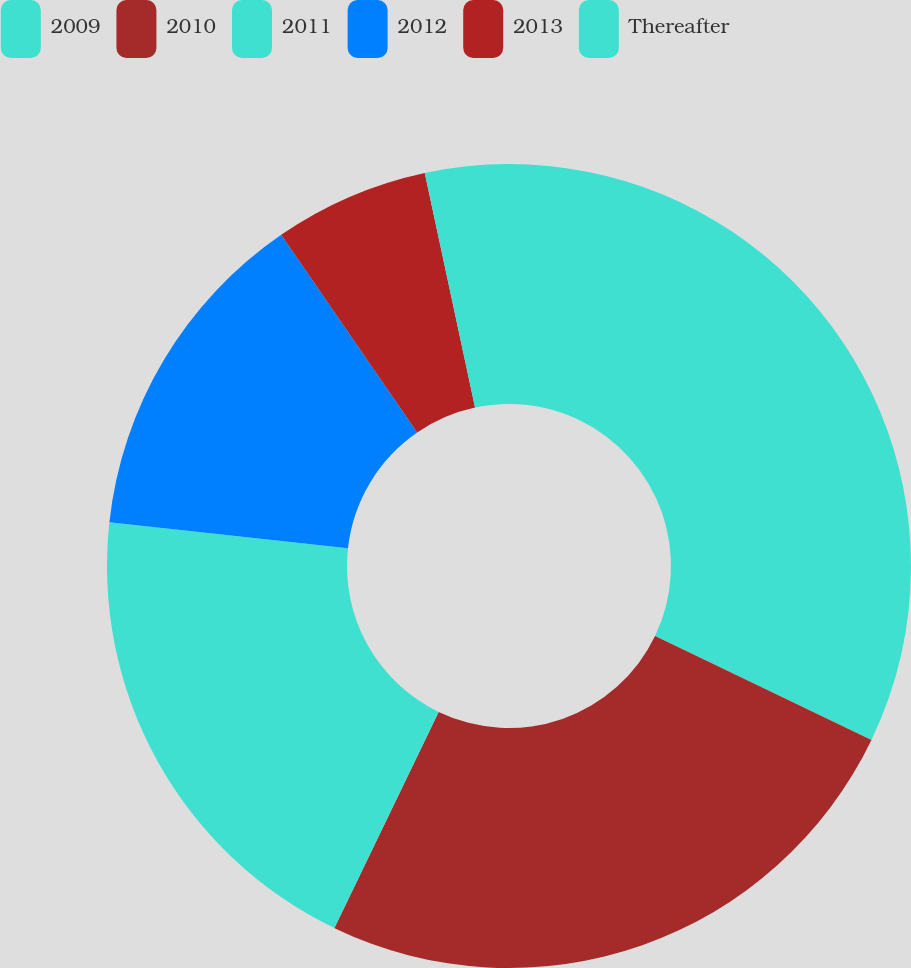Convert chart. <chart><loc_0><loc_0><loc_500><loc_500><pie_chart><fcel>2009<fcel>2010<fcel>2011<fcel>2012<fcel>2013<fcel>Thereafter<nl><fcel>32.12%<fcel>25.03%<fcel>19.59%<fcel>13.67%<fcel>6.23%<fcel>3.36%<nl></chart> 